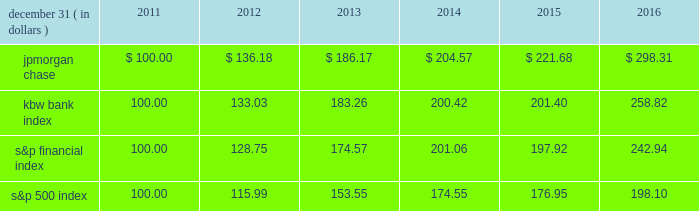Jpmorgan chase & co./2016 annual report 35 five-year stock performance the table and graph compare the five-year cumulative total return for jpmorgan chase & co .
( 201cjpmorgan chase 201d or the 201cfirm 201d ) common stock with the cumulative return of the s&p 500 index , the kbw bank index and the s&p financial index .
The s&p 500 index is a commonly referenced united states of america ( 201cu.s . 201d ) equity benchmark consisting of leading companies from different economic sectors .
The kbw bank index seeks to reflect the performance of banks and thrifts that are publicly traded in the u.s .
And is composed of leading national money center and regional banks and thrifts .
The s&p financial index is an index of financial companies , all of which are components of the s&p 500 .
The firm is a component of all three industry indices .
The table and graph assume simultaneous investments of $ 100 on december 31 , 2011 , in jpmorgan chase common stock and in each of the above indices .
The comparison assumes that all dividends are reinvested .
December 31 , ( in dollars ) 2011 2012 2013 2014 2015 2016 .
December 31 , ( in dollars ) .
What was the 5 year return of the kbw bank index? 
Computations: ((258.82 - 100) / 100)
Answer: 1.5882. 